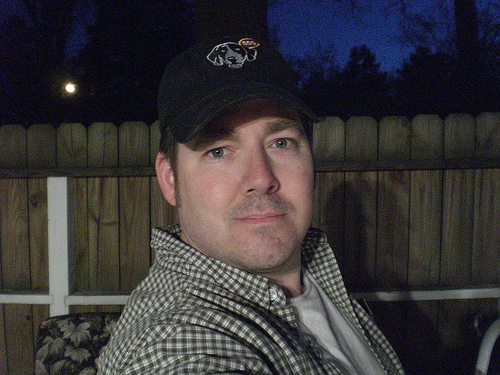<image>
Is there a cap to the left of the fence? No. The cap is not to the left of the fence. From this viewpoint, they have a different horizontal relationship. 